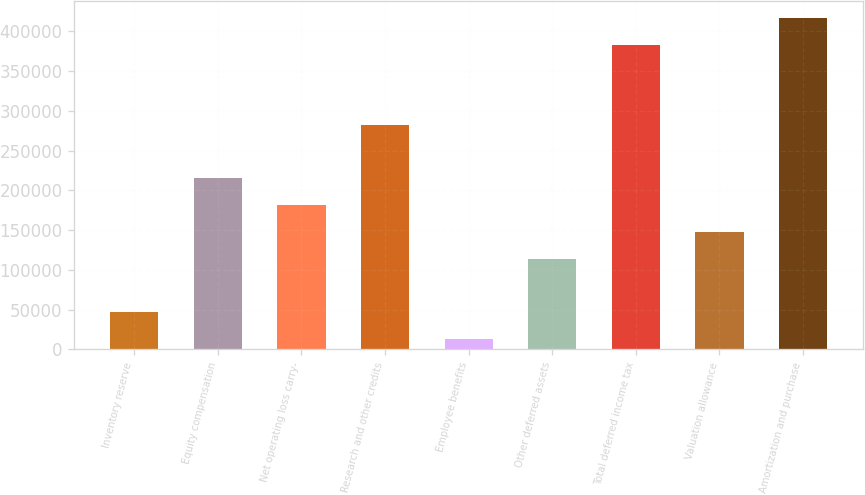Convert chart. <chart><loc_0><loc_0><loc_500><loc_500><bar_chart><fcel>Inventory reserve<fcel>Equity compensation<fcel>Net operating loss carry-<fcel>Research and other credits<fcel>Employee benefits<fcel>Other deferred assets<fcel>Total deferred income tax<fcel>Valuation allowance<fcel>Amortization and purchase<nl><fcel>46898.2<fcel>215154<fcel>181503<fcel>282457<fcel>13247<fcel>114201<fcel>383410<fcel>147852<fcel>417061<nl></chart> 